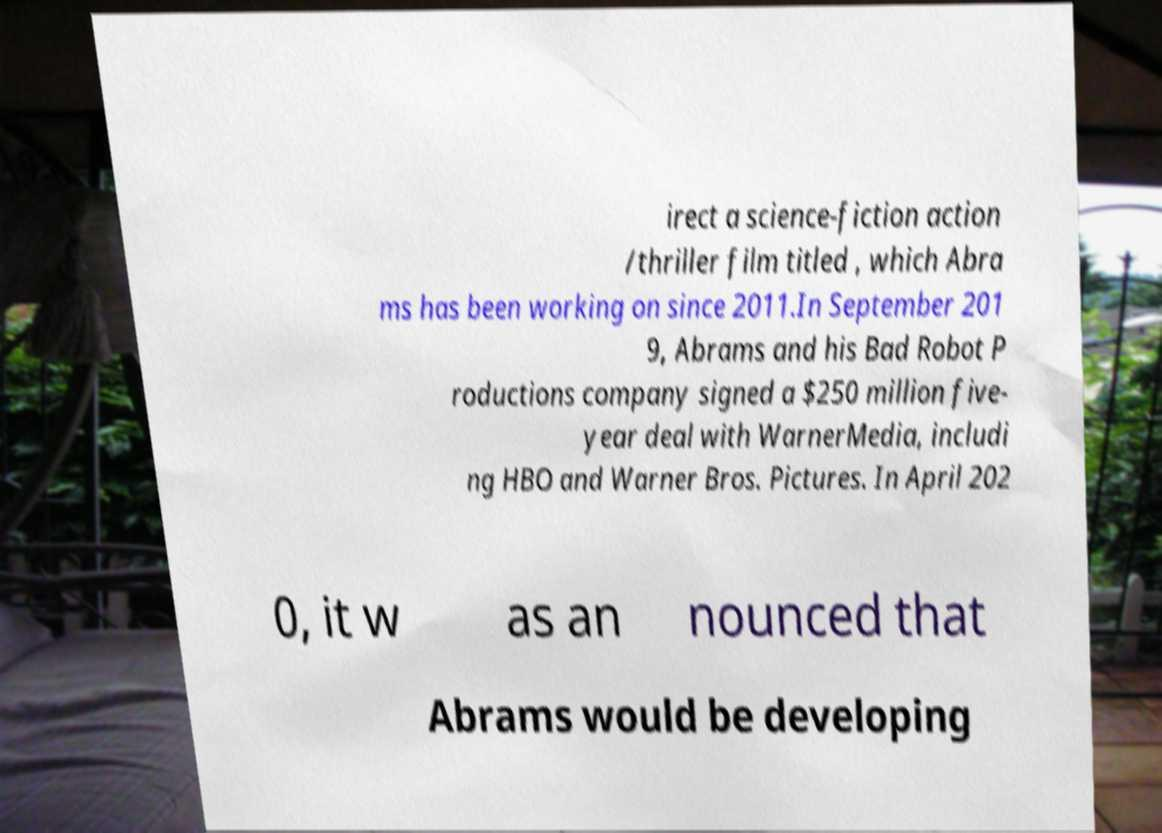Can you accurately transcribe the text from the provided image for me? irect a science-fiction action /thriller film titled , which Abra ms has been working on since 2011.In September 201 9, Abrams and his Bad Robot P roductions company signed a $250 million five- year deal with WarnerMedia, includi ng HBO and Warner Bros. Pictures. In April 202 0, it w as an nounced that Abrams would be developing 